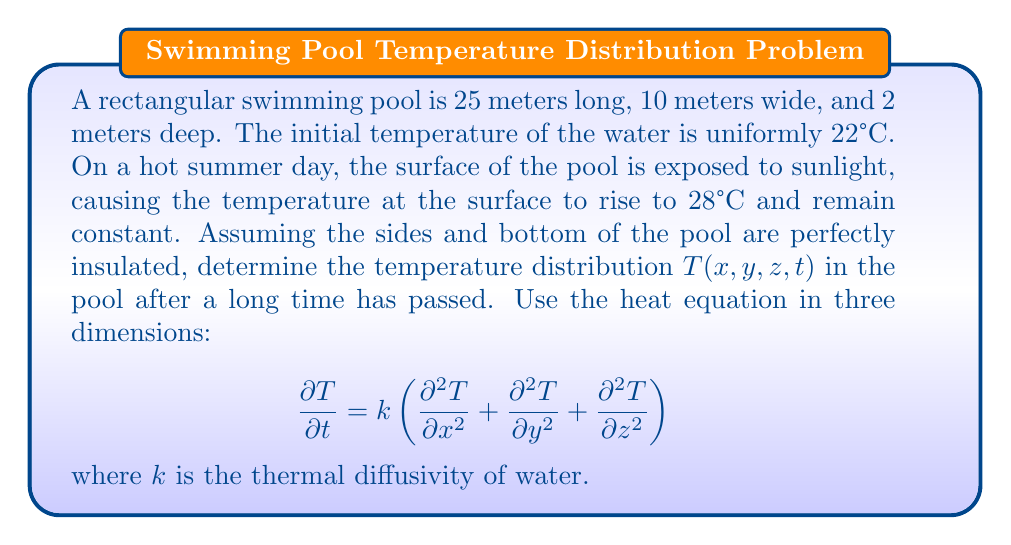Give your solution to this math problem. To solve this problem, we'll follow these steps:

1) First, we need to identify the boundary conditions:
   - At $z = 0$ (surface): $T(x,y,0,t) = 28°C$
   - At $z = 2$ (bottom), $x = 0$, $x = 25$, $y = 0$, and $y = 10$ (sides): $\frac{\partial T}{\partial n} = 0$ (insulated)

2) Given that we're asked for the temperature distribution after a long time, we can assume steady-state conditions, where $\frac{\partial T}{\partial t} = 0$.

3) The steady-state heat equation in 3D reduces to:

   $$\frac{\partial^2 T}{\partial x^2} + \frac{\partial^2 T}{\partial y^2} + \frac{\partial^2 T}{\partial z^2} = 0$$

4) Due to the insulation on the sides and bottom, the temperature will only vary with depth (z). Therefore, we can further simplify to:

   $$\frac{d^2 T}{dz^2} = 0$$

5) The general solution to this equation is:

   $$T(z) = Az + B$$

6) Applying the boundary conditions:
   - At $z = 0$: $T(0) = 28°C$, so $B = 28$
   - At $z = 2$: $\frac{dT}{dz} = 0$, so $A = 0$

7) Therefore, the steady-state temperature distribution is:

   $$T(z) = 28°C$$

This means that after a long time, the temperature throughout the pool will be uniform and equal to the surface temperature.
Answer: $T(x,y,z,t) = 28°C$ (uniform throughout the pool) 